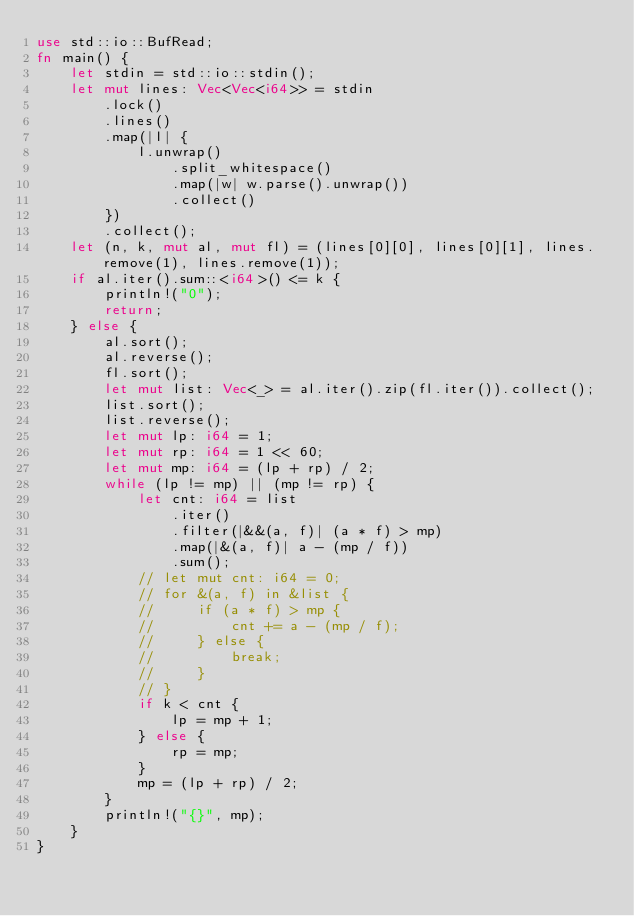<code> <loc_0><loc_0><loc_500><loc_500><_Rust_>use std::io::BufRead;
fn main() {
    let stdin = std::io::stdin();
    let mut lines: Vec<Vec<i64>> = stdin
        .lock()
        .lines()
        .map(|l| {
            l.unwrap()
                .split_whitespace()
                .map(|w| w.parse().unwrap())
                .collect()
        })
        .collect();
    let (n, k, mut al, mut fl) = (lines[0][0], lines[0][1], lines.remove(1), lines.remove(1));
    if al.iter().sum::<i64>() <= k {
        println!("0");
        return;
    } else {
        al.sort();
        al.reverse();
        fl.sort();
        let mut list: Vec<_> = al.iter().zip(fl.iter()).collect();
        list.sort();
        list.reverse();
        let mut lp: i64 = 1;
        let mut rp: i64 = 1 << 60;
        let mut mp: i64 = (lp + rp) / 2;
        while (lp != mp) || (mp != rp) {
            let cnt: i64 = list
                .iter()
                .filter(|&&(a, f)| (a * f) > mp)
                .map(|&(a, f)| a - (mp / f))
                .sum();
            // let mut cnt: i64 = 0;
            // for &(a, f) in &list {
            //     if (a * f) > mp {
            //         cnt += a - (mp / f);
            //     } else {
            //         break;
            //     }
            // }
            if k < cnt {
                lp = mp + 1;
            } else {
                rp = mp;
            }
            mp = (lp + rp) / 2;
        }
        println!("{}", mp);
    }
}
</code> 